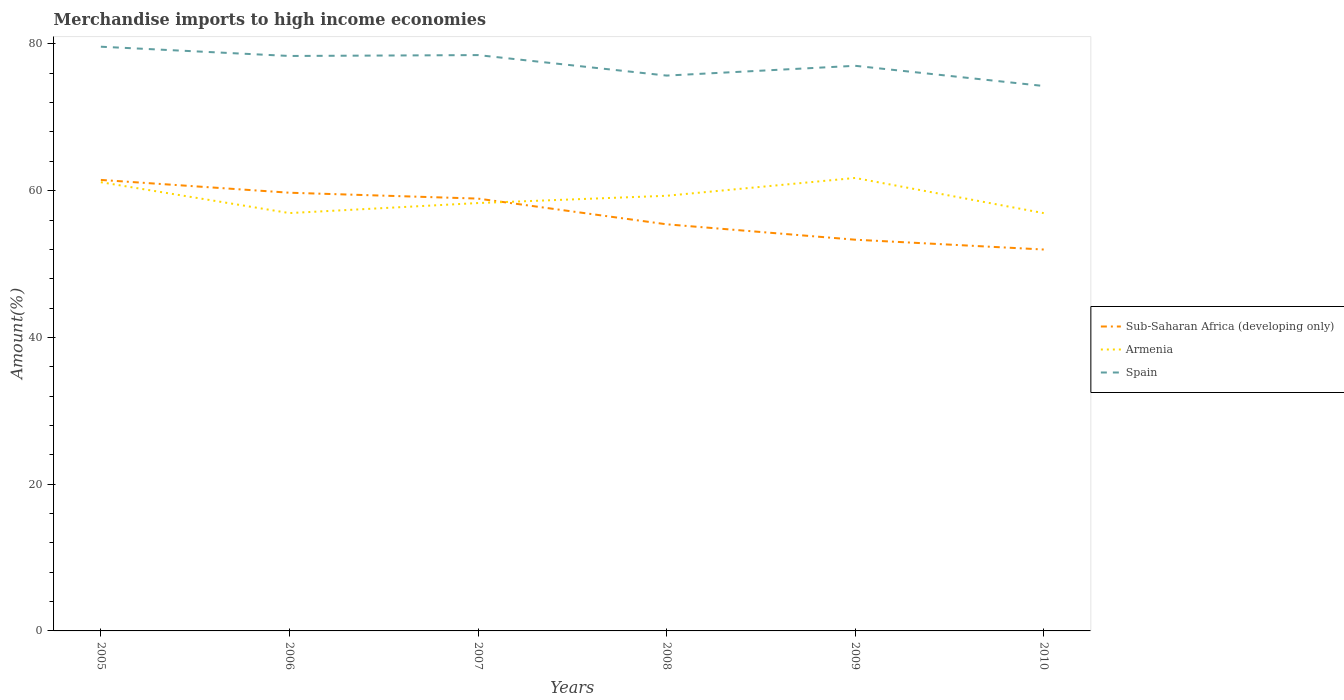How many different coloured lines are there?
Provide a short and direct response. 3. Does the line corresponding to Spain intersect with the line corresponding to Sub-Saharan Africa (developing only)?
Your response must be concise. No. Is the number of lines equal to the number of legend labels?
Offer a terse response. Yes. Across all years, what is the maximum percentage of amount earned from merchandise imports in Armenia?
Ensure brevity in your answer.  56.94. What is the total percentage of amount earned from merchandise imports in Spain in the graph?
Provide a succinct answer. 4.21. What is the difference between the highest and the second highest percentage of amount earned from merchandise imports in Sub-Saharan Africa (developing only)?
Make the answer very short. 9.49. Is the percentage of amount earned from merchandise imports in Sub-Saharan Africa (developing only) strictly greater than the percentage of amount earned from merchandise imports in Spain over the years?
Your answer should be compact. Yes. How many years are there in the graph?
Keep it short and to the point. 6. Are the values on the major ticks of Y-axis written in scientific E-notation?
Give a very brief answer. No. Does the graph contain any zero values?
Offer a terse response. No. Where does the legend appear in the graph?
Make the answer very short. Center right. How many legend labels are there?
Provide a succinct answer. 3. How are the legend labels stacked?
Make the answer very short. Vertical. What is the title of the graph?
Your answer should be very brief. Merchandise imports to high income economies. Does "Haiti" appear as one of the legend labels in the graph?
Keep it short and to the point. No. What is the label or title of the Y-axis?
Ensure brevity in your answer.  Amount(%). What is the Amount(%) in Sub-Saharan Africa (developing only) in 2005?
Provide a short and direct response. 61.46. What is the Amount(%) of Armenia in 2005?
Provide a succinct answer. 61.15. What is the Amount(%) of Spain in 2005?
Ensure brevity in your answer.  79.62. What is the Amount(%) in Sub-Saharan Africa (developing only) in 2006?
Your response must be concise. 59.72. What is the Amount(%) in Armenia in 2006?
Ensure brevity in your answer.  56.95. What is the Amount(%) in Spain in 2006?
Your answer should be very brief. 78.36. What is the Amount(%) of Sub-Saharan Africa (developing only) in 2007?
Provide a short and direct response. 58.92. What is the Amount(%) of Armenia in 2007?
Your response must be concise. 58.31. What is the Amount(%) of Spain in 2007?
Provide a succinct answer. 78.48. What is the Amount(%) of Sub-Saharan Africa (developing only) in 2008?
Provide a short and direct response. 55.42. What is the Amount(%) in Armenia in 2008?
Your response must be concise. 59.3. What is the Amount(%) of Spain in 2008?
Ensure brevity in your answer.  75.68. What is the Amount(%) in Sub-Saharan Africa (developing only) in 2009?
Your response must be concise. 53.32. What is the Amount(%) in Armenia in 2009?
Provide a succinct answer. 61.73. What is the Amount(%) in Spain in 2009?
Keep it short and to the point. 77.02. What is the Amount(%) of Sub-Saharan Africa (developing only) in 2010?
Make the answer very short. 51.98. What is the Amount(%) of Armenia in 2010?
Provide a short and direct response. 56.94. What is the Amount(%) in Spain in 2010?
Make the answer very short. 74.26. Across all years, what is the maximum Amount(%) in Sub-Saharan Africa (developing only)?
Ensure brevity in your answer.  61.46. Across all years, what is the maximum Amount(%) in Armenia?
Keep it short and to the point. 61.73. Across all years, what is the maximum Amount(%) in Spain?
Keep it short and to the point. 79.62. Across all years, what is the minimum Amount(%) of Sub-Saharan Africa (developing only)?
Your answer should be compact. 51.98. Across all years, what is the minimum Amount(%) in Armenia?
Make the answer very short. 56.94. Across all years, what is the minimum Amount(%) in Spain?
Make the answer very short. 74.26. What is the total Amount(%) in Sub-Saharan Africa (developing only) in the graph?
Offer a very short reply. 340.82. What is the total Amount(%) of Armenia in the graph?
Your answer should be compact. 354.39. What is the total Amount(%) of Spain in the graph?
Provide a succinct answer. 463.42. What is the difference between the Amount(%) of Sub-Saharan Africa (developing only) in 2005 and that in 2006?
Offer a very short reply. 1.74. What is the difference between the Amount(%) of Armenia in 2005 and that in 2006?
Your answer should be very brief. 4.21. What is the difference between the Amount(%) of Spain in 2005 and that in 2006?
Keep it short and to the point. 1.26. What is the difference between the Amount(%) in Sub-Saharan Africa (developing only) in 2005 and that in 2007?
Keep it short and to the point. 2.55. What is the difference between the Amount(%) in Armenia in 2005 and that in 2007?
Your answer should be compact. 2.84. What is the difference between the Amount(%) of Spain in 2005 and that in 2007?
Give a very brief answer. 1.14. What is the difference between the Amount(%) of Sub-Saharan Africa (developing only) in 2005 and that in 2008?
Your answer should be very brief. 6.05. What is the difference between the Amount(%) of Armenia in 2005 and that in 2008?
Make the answer very short. 1.85. What is the difference between the Amount(%) in Spain in 2005 and that in 2008?
Provide a short and direct response. 3.93. What is the difference between the Amount(%) in Sub-Saharan Africa (developing only) in 2005 and that in 2009?
Provide a succinct answer. 8.15. What is the difference between the Amount(%) in Armenia in 2005 and that in 2009?
Your answer should be compact. -0.58. What is the difference between the Amount(%) of Spain in 2005 and that in 2009?
Offer a terse response. 2.6. What is the difference between the Amount(%) in Sub-Saharan Africa (developing only) in 2005 and that in 2010?
Your response must be concise. 9.49. What is the difference between the Amount(%) in Armenia in 2005 and that in 2010?
Your answer should be very brief. 4.21. What is the difference between the Amount(%) of Spain in 2005 and that in 2010?
Provide a succinct answer. 5.35. What is the difference between the Amount(%) in Sub-Saharan Africa (developing only) in 2006 and that in 2007?
Your response must be concise. 0.8. What is the difference between the Amount(%) of Armenia in 2006 and that in 2007?
Your response must be concise. -1.37. What is the difference between the Amount(%) in Spain in 2006 and that in 2007?
Provide a succinct answer. -0.12. What is the difference between the Amount(%) of Sub-Saharan Africa (developing only) in 2006 and that in 2008?
Provide a succinct answer. 4.3. What is the difference between the Amount(%) of Armenia in 2006 and that in 2008?
Your response must be concise. -2.36. What is the difference between the Amount(%) of Spain in 2006 and that in 2008?
Make the answer very short. 2.67. What is the difference between the Amount(%) of Sub-Saharan Africa (developing only) in 2006 and that in 2009?
Your response must be concise. 6.4. What is the difference between the Amount(%) of Armenia in 2006 and that in 2009?
Offer a very short reply. -4.79. What is the difference between the Amount(%) of Spain in 2006 and that in 2009?
Keep it short and to the point. 1.34. What is the difference between the Amount(%) of Sub-Saharan Africa (developing only) in 2006 and that in 2010?
Offer a terse response. 7.74. What is the difference between the Amount(%) in Armenia in 2006 and that in 2010?
Make the answer very short. 0.01. What is the difference between the Amount(%) in Spain in 2006 and that in 2010?
Provide a short and direct response. 4.09. What is the difference between the Amount(%) in Sub-Saharan Africa (developing only) in 2007 and that in 2008?
Provide a short and direct response. 3.5. What is the difference between the Amount(%) in Armenia in 2007 and that in 2008?
Keep it short and to the point. -0.99. What is the difference between the Amount(%) of Spain in 2007 and that in 2008?
Your response must be concise. 2.79. What is the difference between the Amount(%) of Sub-Saharan Africa (developing only) in 2007 and that in 2009?
Make the answer very short. 5.6. What is the difference between the Amount(%) in Armenia in 2007 and that in 2009?
Offer a terse response. -3.42. What is the difference between the Amount(%) in Spain in 2007 and that in 2009?
Your response must be concise. 1.46. What is the difference between the Amount(%) of Sub-Saharan Africa (developing only) in 2007 and that in 2010?
Give a very brief answer. 6.94. What is the difference between the Amount(%) in Armenia in 2007 and that in 2010?
Provide a succinct answer. 1.37. What is the difference between the Amount(%) in Spain in 2007 and that in 2010?
Provide a succinct answer. 4.21. What is the difference between the Amount(%) of Sub-Saharan Africa (developing only) in 2008 and that in 2009?
Offer a terse response. 2.1. What is the difference between the Amount(%) of Armenia in 2008 and that in 2009?
Provide a succinct answer. -2.43. What is the difference between the Amount(%) in Spain in 2008 and that in 2009?
Your response must be concise. -1.33. What is the difference between the Amount(%) of Sub-Saharan Africa (developing only) in 2008 and that in 2010?
Ensure brevity in your answer.  3.44. What is the difference between the Amount(%) in Armenia in 2008 and that in 2010?
Provide a succinct answer. 2.37. What is the difference between the Amount(%) of Spain in 2008 and that in 2010?
Make the answer very short. 1.42. What is the difference between the Amount(%) in Sub-Saharan Africa (developing only) in 2009 and that in 2010?
Offer a terse response. 1.34. What is the difference between the Amount(%) of Armenia in 2009 and that in 2010?
Your answer should be very brief. 4.79. What is the difference between the Amount(%) in Spain in 2009 and that in 2010?
Your response must be concise. 2.75. What is the difference between the Amount(%) of Sub-Saharan Africa (developing only) in 2005 and the Amount(%) of Armenia in 2006?
Your response must be concise. 4.52. What is the difference between the Amount(%) in Sub-Saharan Africa (developing only) in 2005 and the Amount(%) in Spain in 2006?
Provide a succinct answer. -16.89. What is the difference between the Amount(%) in Armenia in 2005 and the Amount(%) in Spain in 2006?
Your answer should be very brief. -17.2. What is the difference between the Amount(%) in Sub-Saharan Africa (developing only) in 2005 and the Amount(%) in Armenia in 2007?
Your answer should be compact. 3.15. What is the difference between the Amount(%) in Sub-Saharan Africa (developing only) in 2005 and the Amount(%) in Spain in 2007?
Ensure brevity in your answer.  -17.01. What is the difference between the Amount(%) of Armenia in 2005 and the Amount(%) of Spain in 2007?
Offer a terse response. -17.32. What is the difference between the Amount(%) in Sub-Saharan Africa (developing only) in 2005 and the Amount(%) in Armenia in 2008?
Keep it short and to the point. 2.16. What is the difference between the Amount(%) of Sub-Saharan Africa (developing only) in 2005 and the Amount(%) of Spain in 2008?
Your answer should be very brief. -14.22. What is the difference between the Amount(%) in Armenia in 2005 and the Amount(%) in Spain in 2008?
Your response must be concise. -14.53. What is the difference between the Amount(%) of Sub-Saharan Africa (developing only) in 2005 and the Amount(%) of Armenia in 2009?
Ensure brevity in your answer.  -0.27. What is the difference between the Amount(%) in Sub-Saharan Africa (developing only) in 2005 and the Amount(%) in Spain in 2009?
Make the answer very short. -15.55. What is the difference between the Amount(%) in Armenia in 2005 and the Amount(%) in Spain in 2009?
Offer a terse response. -15.87. What is the difference between the Amount(%) of Sub-Saharan Africa (developing only) in 2005 and the Amount(%) of Armenia in 2010?
Make the answer very short. 4.53. What is the difference between the Amount(%) of Sub-Saharan Africa (developing only) in 2005 and the Amount(%) of Spain in 2010?
Give a very brief answer. -12.8. What is the difference between the Amount(%) of Armenia in 2005 and the Amount(%) of Spain in 2010?
Provide a succinct answer. -13.11. What is the difference between the Amount(%) in Sub-Saharan Africa (developing only) in 2006 and the Amount(%) in Armenia in 2007?
Provide a short and direct response. 1.41. What is the difference between the Amount(%) in Sub-Saharan Africa (developing only) in 2006 and the Amount(%) in Spain in 2007?
Give a very brief answer. -18.76. What is the difference between the Amount(%) of Armenia in 2006 and the Amount(%) of Spain in 2007?
Ensure brevity in your answer.  -21.53. What is the difference between the Amount(%) in Sub-Saharan Africa (developing only) in 2006 and the Amount(%) in Armenia in 2008?
Give a very brief answer. 0.42. What is the difference between the Amount(%) of Sub-Saharan Africa (developing only) in 2006 and the Amount(%) of Spain in 2008?
Offer a terse response. -15.96. What is the difference between the Amount(%) in Armenia in 2006 and the Amount(%) in Spain in 2008?
Provide a succinct answer. -18.74. What is the difference between the Amount(%) in Sub-Saharan Africa (developing only) in 2006 and the Amount(%) in Armenia in 2009?
Ensure brevity in your answer.  -2.01. What is the difference between the Amount(%) in Sub-Saharan Africa (developing only) in 2006 and the Amount(%) in Spain in 2009?
Your response must be concise. -17.3. What is the difference between the Amount(%) in Armenia in 2006 and the Amount(%) in Spain in 2009?
Provide a short and direct response. -20.07. What is the difference between the Amount(%) in Sub-Saharan Africa (developing only) in 2006 and the Amount(%) in Armenia in 2010?
Your answer should be very brief. 2.78. What is the difference between the Amount(%) in Sub-Saharan Africa (developing only) in 2006 and the Amount(%) in Spain in 2010?
Provide a succinct answer. -14.54. What is the difference between the Amount(%) in Armenia in 2006 and the Amount(%) in Spain in 2010?
Give a very brief answer. -17.32. What is the difference between the Amount(%) of Sub-Saharan Africa (developing only) in 2007 and the Amount(%) of Armenia in 2008?
Keep it short and to the point. -0.39. What is the difference between the Amount(%) in Sub-Saharan Africa (developing only) in 2007 and the Amount(%) in Spain in 2008?
Your response must be concise. -16.77. What is the difference between the Amount(%) in Armenia in 2007 and the Amount(%) in Spain in 2008?
Offer a very short reply. -17.37. What is the difference between the Amount(%) in Sub-Saharan Africa (developing only) in 2007 and the Amount(%) in Armenia in 2009?
Your response must be concise. -2.81. What is the difference between the Amount(%) in Sub-Saharan Africa (developing only) in 2007 and the Amount(%) in Spain in 2009?
Provide a short and direct response. -18.1. What is the difference between the Amount(%) in Armenia in 2007 and the Amount(%) in Spain in 2009?
Provide a short and direct response. -18.7. What is the difference between the Amount(%) in Sub-Saharan Africa (developing only) in 2007 and the Amount(%) in Armenia in 2010?
Keep it short and to the point. 1.98. What is the difference between the Amount(%) in Sub-Saharan Africa (developing only) in 2007 and the Amount(%) in Spain in 2010?
Your response must be concise. -15.35. What is the difference between the Amount(%) in Armenia in 2007 and the Amount(%) in Spain in 2010?
Your answer should be very brief. -15.95. What is the difference between the Amount(%) of Sub-Saharan Africa (developing only) in 2008 and the Amount(%) of Armenia in 2009?
Provide a short and direct response. -6.32. What is the difference between the Amount(%) in Sub-Saharan Africa (developing only) in 2008 and the Amount(%) in Spain in 2009?
Provide a succinct answer. -21.6. What is the difference between the Amount(%) in Armenia in 2008 and the Amount(%) in Spain in 2009?
Make the answer very short. -17.71. What is the difference between the Amount(%) in Sub-Saharan Africa (developing only) in 2008 and the Amount(%) in Armenia in 2010?
Offer a very short reply. -1.52. What is the difference between the Amount(%) of Sub-Saharan Africa (developing only) in 2008 and the Amount(%) of Spain in 2010?
Give a very brief answer. -18.85. What is the difference between the Amount(%) of Armenia in 2008 and the Amount(%) of Spain in 2010?
Your answer should be very brief. -14.96. What is the difference between the Amount(%) of Sub-Saharan Africa (developing only) in 2009 and the Amount(%) of Armenia in 2010?
Keep it short and to the point. -3.62. What is the difference between the Amount(%) in Sub-Saharan Africa (developing only) in 2009 and the Amount(%) in Spain in 2010?
Offer a terse response. -20.95. What is the difference between the Amount(%) of Armenia in 2009 and the Amount(%) of Spain in 2010?
Provide a succinct answer. -12.53. What is the average Amount(%) of Sub-Saharan Africa (developing only) per year?
Make the answer very short. 56.8. What is the average Amount(%) in Armenia per year?
Your response must be concise. 59.06. What is the average Amount(%) in Spain per year?
Your response must be concise. 77.24. In the year 2005, what is the difference between the Amount(%) of Sub-Saharan Africa (developing only) and Amount(%) of Armenia?
Provide a short and direct response. 0.31. In the year 2005, what is the difference between the Amount(%) in Sub-Saharan Africa (developing only) and Amount(%) in Spain?
Provide a short and direct response. -18.15. In the year 2005, what is the difference between the Amount(%) of Armenia and Amount(%) of Spain?
Your response must be concise. -18.47. In the year 2006, what is the difference between the Amount(%) of Sub-Saharan Africa (developing only) and Amount(%) of Armenia?
Offer a terse response. 2.77. In the year 2006, what is the difference between the Amount(%) of Sub-Saharan Africa (developing only) and Amount(%) of Spain?
Your response must be concise. -18.64. In the year 2006, what is the difference between the Amount(%) of Armenia and Amount(%) of Spain?
Provide a short and direct response. -21.41. In the year 2007, what is the difference between the Amount(%) in Sub-Saharan Africa (developing only) and Amount(%) in Armenia?
Ensure brevity in your answer.  0.61. In the year 2007, what is the difference between the Amount(%) in Sub-Saharan Africa (developing only) and Amount(%) in Spain?
Your response must be concise. -19.56. In the year 2007, what is the difference between the Amount(%) in Armenia and Amount(%) in Spain?
Keep it short and to the point. -20.16. In the year 2008, what is the difference between the Amount(%) of Sub-Saharan Africa (developing only) and Amount(%) of Armenia?
Give a very brief answer. -3.89. In the year 2008, what is the difference between the Amount(%) of Sub-Saharan Africa (developing only) and Amount(%) of Spain?
Your answer should be compact. -20.27. In the year 2008, what is the difference between the Amount(%) in Armenia and Amount(%) in Spain?
Make the answer very short. -16.38. In the year 2009, what is the difference between the Amount(%) of Sub-Saharan Africa (developing only) and Amount(%) of Armenia?
Your answer should be compact. -8.41. In the year 2009, what is the difference between the Amount(%) in Sub-Saharan Africa (developing only) and Amount(%) in Spain?
Ensure brevity in your answer.  -23.7. In the year 2009, what is the difference between the Amount(%) in Armenia and Amount(%) in Spain?
Ensure brevity in your answer.  -15.29. In the year 2010, what is the difference between the Amount(%) in Sub-Saharan Africa (developing only) and Amount(%) in Armenia?
Make the answer very short. -4.96. In the year 2010, what is the difference between the Amount(%) of Sub-Saharan Africa (developing only) and Amount(%) of Spain?
Provide a succinct answer. -22.29. In the year 2010, what is the difference between the Amount(%) in Armenia and Amount(%) in Spain?
Offer a very short reply. -17.33. What is the ratio of the Amount(%) of Sub-Saharan Africa (developing only) in 2005 to that in 2006?
Provide a short and direct response. 1.03. What is the ratio of the Amount(%) in Armenia in 2005 to that in 2006?
Ensure brevity in your answer.  1.07. What is the ratio of the Amount(%) of Spain in 2005 to that in 2006?
Provide a succinct answer. 1.02. What is the ratio of the Amount(%) of Sub-Saharan Africa (developing only) in 2005 to that in 2007?
Your response must be concise. 1.04. What is the ratio of the Amount(%) in Armenia in 2005 to that in 2007?
Make the answer very short. 1.05. What is the ratio of the Amount(%) in Spain in 2005 to that in 2007?
Your answer should be compact. 1.01. What is the ratio of the Amount(%) in Sub-Saharan Africa (developing only) in 2005 to that in 2008?
Give a very brief answer. 1.11. What is the ratio of the Amount(%) in Armenia in 2005 to that in 2008?
Offer a very short reply. 1.03. What is the ratio of the Amount(%) of Spain in 2005 to that in 2008?
Provide a succinct answer. 1.05. What is the ratio of the Amount(%) of Sub-Saharan Africa (developing only) in 2005 to that in 2009?
Your answer should be very brief. 1.15. What is the ratio of the Amount(%) of Armenia in 2005 to that in 2009?
Make the answer very short. 0.99. What is the ratio of the Amount(%) in Spain in 2005 to that in 2009?
Ensure brevity in your answer.  1.03. What is the ratio of the Amount(%) in Sub-Saharan Africa (developing only) in 2005 to that in 2010?
Offer a terse response. 1.18. What is the ratio of the Amount(%) of Armenia in 2005 to that in 2010?
Offer a terse response. 1.07. What is the ratio of the Amount(%) in Spain in 2005 to that in 2010?
Give a very brief answer. 1.07. What is the ratio of the Amount(%) in Sub-Saharan Africa (developing only) in 2006 to that in 2007?
Your response must be concise. 1.01. What is the ratio of the Amount(%) in Armenia in 2006 to that in 2007?
Your answer should be compact. 0.98. What is the ratio of the Amount(%) of Sub-Saharan Africa (developing only) in 2006 to that in 2008?
Ensure brevity in your answer.  1.08. What is the ratio of the Amount(%) of Armenia in 2006 to that in 2008?
Ensure brevity in your answer.  0.96. What is the ratio of the Amount(%) in Spain in 2006 to that in 2008?
Give a very brief answer. 1.04. What is the ratio of the Amount(%) of Sub-Saharan Africa (developing only) in 2006 to that in 2009?
Keep it short and to the point. 1.12. What is the ratio of the Amount(%) in Armenia in 2006 to that in 2009?
Make the answer very short. 0.92. What is the ratio of the Amount(%) in Spain in 2006 to that in 2009?
Keep it short and to the point. 1.02. What is the ratio of the Amount(%) in Sub-Saharan Africa (developing only) in 2006 to that in 2010?
Provide a succinct answer. 1.15. What is the ratio of the Amount(%) of Spain in 2006 to that in 2010?
Provide a succinct answer. 1.06. What is the ratio of the Amount(%) in Sub-Saharan Africa (developing only) in 2007 to that in 2008?
Your answer should be compact. 1.06. What is the ratio of the Amount(%) in Armenia in 2007 to that in 2008?
Give a very brief answer. 0.98. What is the ratio of the Amount(%) in Spain in 2007 to that in 2008?
Give a very brief answer. 1.04. What is the ratio of the Amount(%) of Sub-Saharan Africa (developing only) in 2007 to that in 2009?
Provide a short and direct response. 1.11. What is the ratio of the Amount(%) of Armenia in 2007 to that in 2009?
Your answer should be very brief. 0.94. What is the ratio of the Amount(%) of Spain in 2007 to that in 2009?
Your answer should be compact. 1.02. What is the ratio of the Amount(%) of Sub-Saharan Africa (developing only) in 2007 to that in 2010?
Ensure brevity in your answer.  1.13. What is the ratio of the Amount(%) of Armenia in 2007 to that in 2010?
Your answer should be very brief. 1.02. What is the ratio of the Amount(%) in Spain in 2007 to that in 2010?
Keep it short and to the point. 1.06. What is the ratio of the Amount(%) in Sub-Saharan Africa (developing only) in 2008 to that in 2009?
Provide a short and direct response. 1.04. What is the ratio of the Amount(%) of Armenia in 2008 to that in 2009?
Ensure brevity in your answer.  0.96. What is the ratio of the Amount(%) of Spain in 2008 to that in 2009?
Your answer should be compact. 0.98. What is the ratio of the Amount(%) of Sub-Saharan Africa (developing only) in 2008 to that in 2010?
Offer a terse response. 1.07. What is the ratio of the Amount(%) of Armenia in 2008 to that in 2010?
Provide a short and direct response. 1.04. What is the ratio of the Amount(%) in Spain in 2008 to that in 2010?
Ensure brevity in your answer.  1.02. What is the ratio of the Amount(%) of Sub-Saharan Africa (developing only) in 2009 to that in 2010?
Make the answer very short. 1.03. What is the ratio of the Amount(%) of Armenia in 2009 to that in 2010?
Your answer should be compact. 1.08. What is the ratio of the Amount(%) in Spain in 2009 to that in 2010?
Keep it short and to the point. 1.04. What is the difference between the highest and the second highest Amount(%) of Sub-Saharan Africa (developing only)?
Keep it short and to the point. 1.74. What is the difference between the highest and the second highest Amount(%) in Armenia?
Keep it short and to the point. 0.58. What is the difference between the highest and the second highest Amount(%) in Spain?
Provide a short and direct response. 1.14. What is the difference between the highest and the lowest Amount(%) in Sub-Saharan Africa (developing only)?
Your answer should be very brief. 9.49. What is the difference between the highest and the lowest Amount(%) of Armenia?
Your answer should be compact. 4.79. What is the difference between the highest and the lowest Amount(%) of Spain?
Provide a short and direct response. 5.35. 